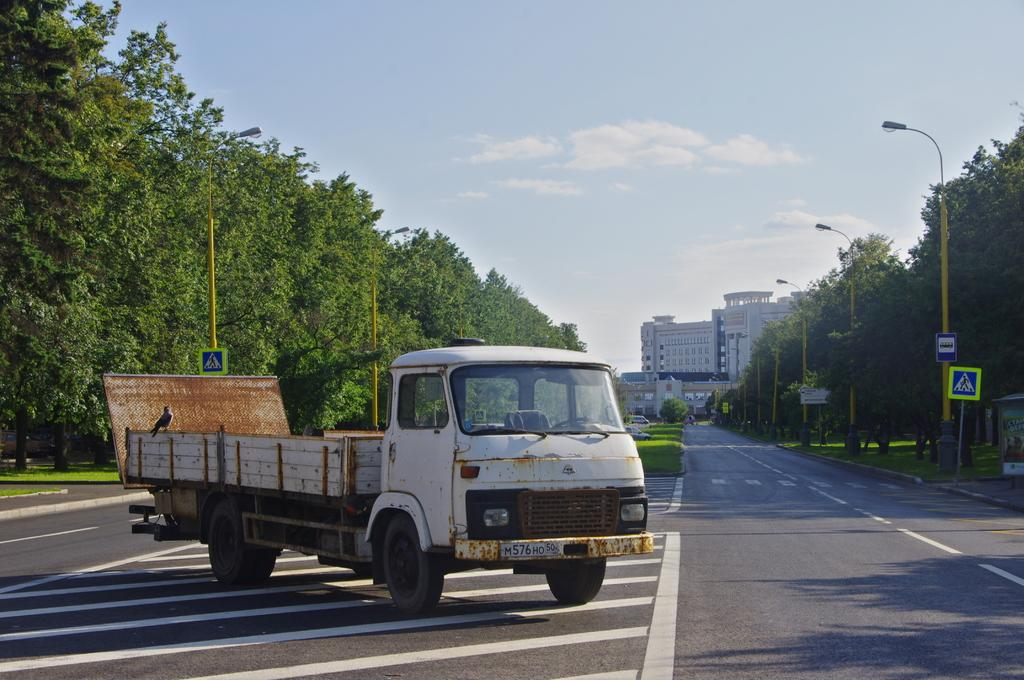What is the main subject in the middle of the image? There is a truck in the middle of the road in the image. What can be seen on either side of the road? Trees are present on either side of the road in the image. What type of landscape is the road located on? The road is on a grassland. What is visible in the background of the image? There are buildings and the sky in the background of the image. What is the condition of the sky in the image? Clouds are present in the sky. What type of drink is being offered to the sheep in the image? There are no sheep or drinks present in the image. What is the pencil being used for in the image? There is no pencil present in the image. 